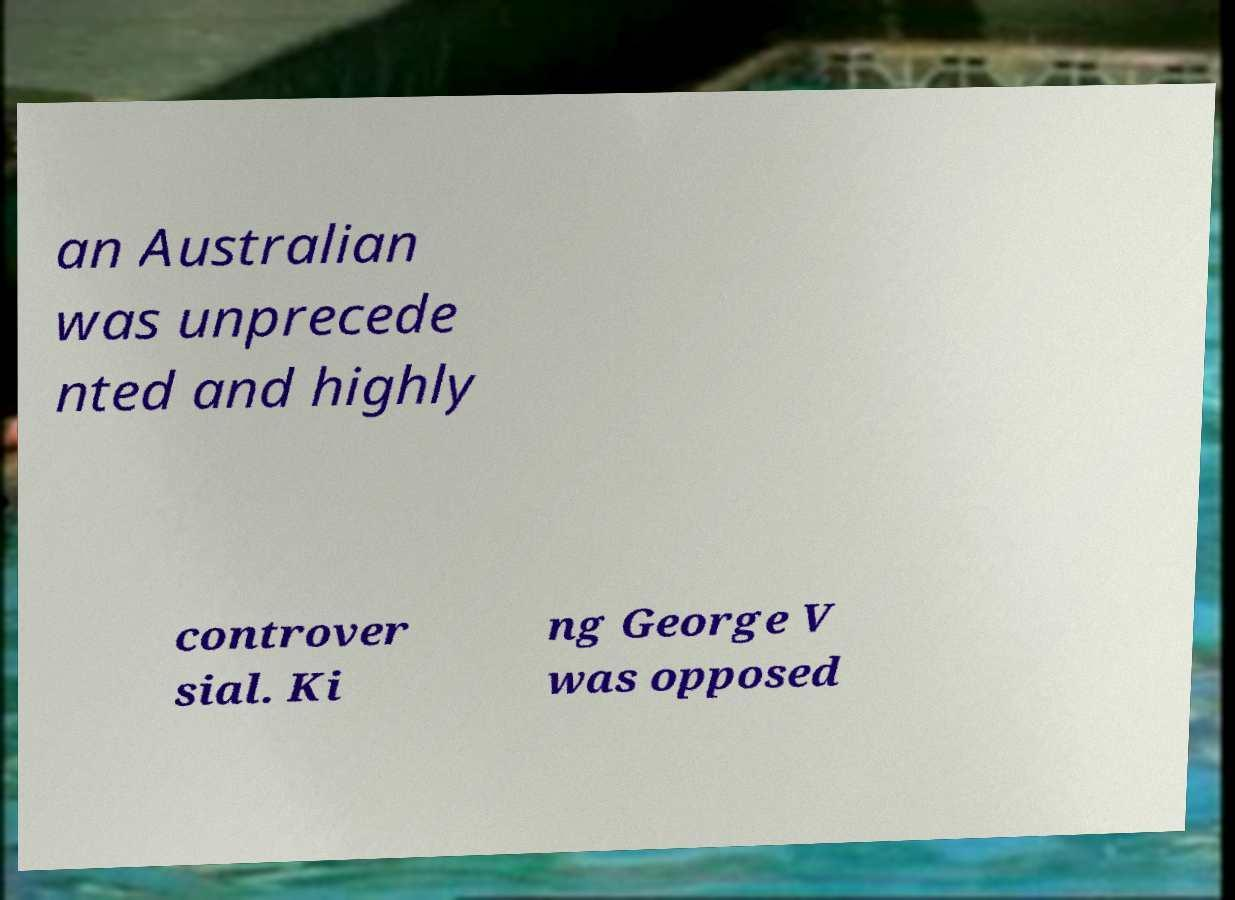Can you accurately transcribe the text from the provided image for me? an Australian was unprecede nted and highly controver sial. Ki ng George V was opposed 